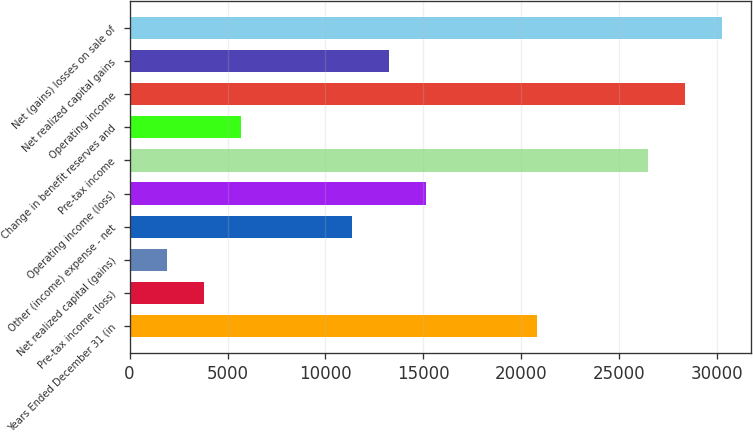Convert chart. <chart><loc_0><loc_0><loc_500><loc_500><bar_chart><fcel>Years Ended December 31 (in<fcel>Pre-tax income (loss)<fcel>Net realized capital (gains)<fcel>Other (income) expense - net<fcel>Operating income (loss)<fcel>Pre-tax income<fcel>Change in benefit reserves and<fcel>Operating income<fcel>Net realized capital gains<fcel>Net (gains) losses on sale of<nl><fcel>20786.4<fcel>3781.8<fcel>1892.4<fcel>11339.4<fcel>15118.2<fcel>26454.6<fcel>5671.2<fcel>28344<fcel>13228.8<fcel>30233.4<nl></chart> 